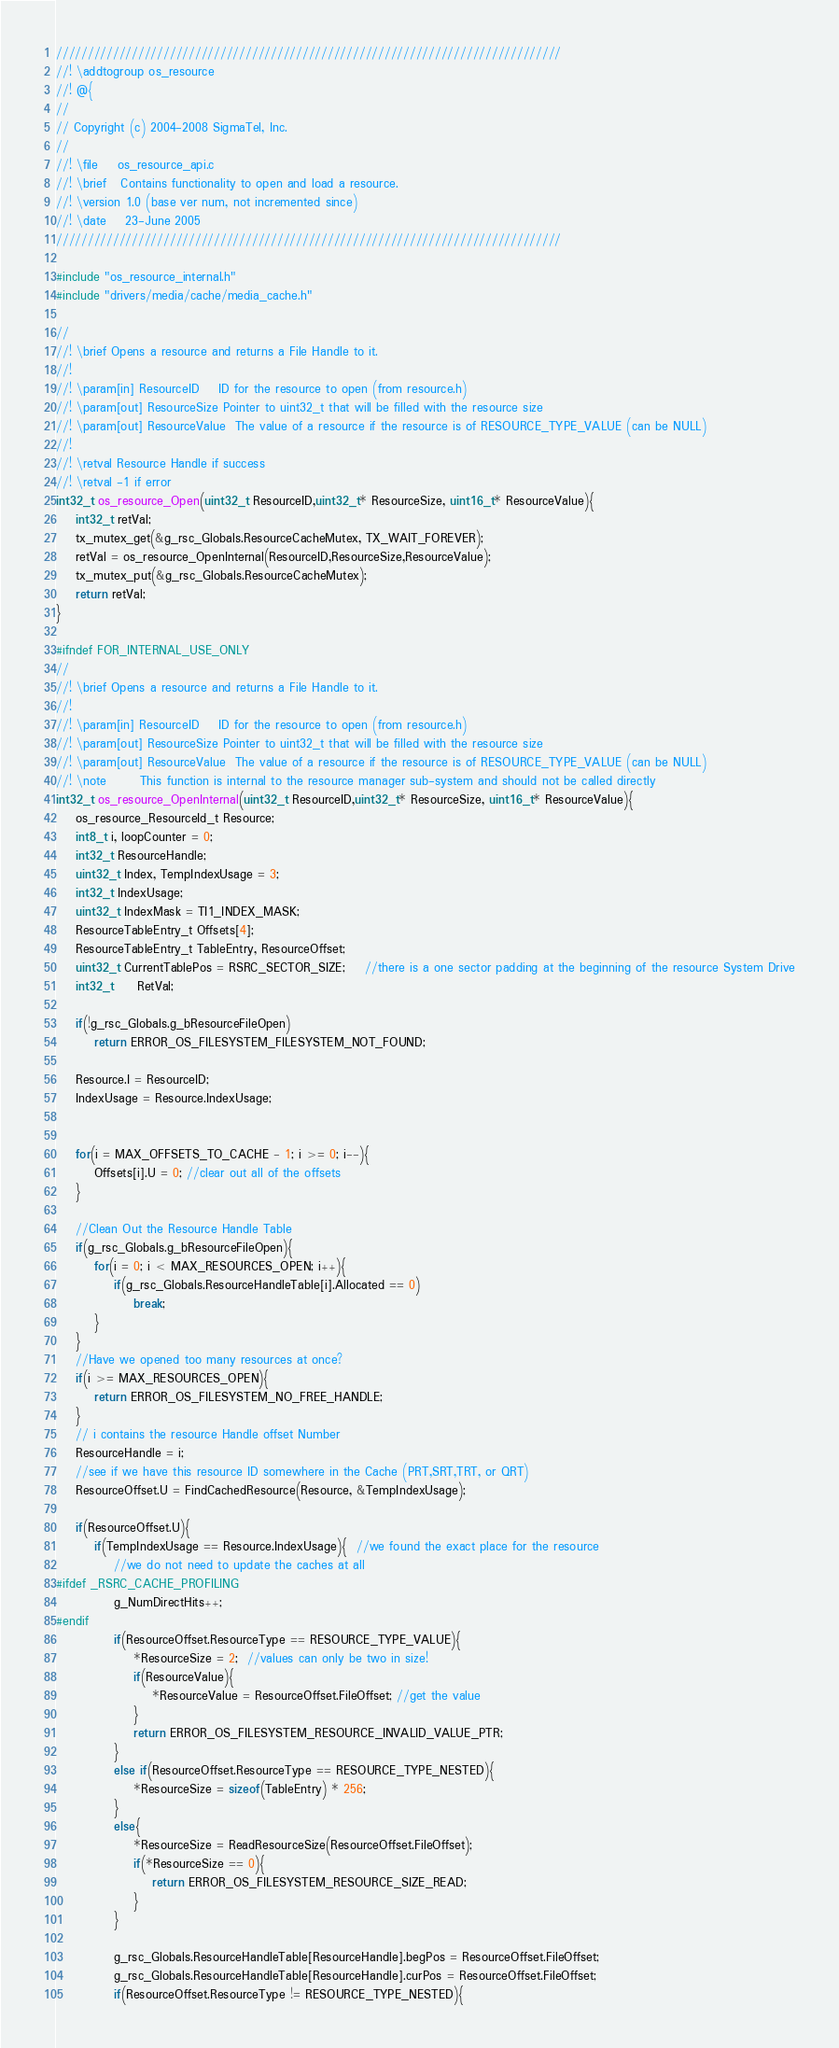Convert code to text. <code><loc_0><loc_0><loc_500><loc_500><_C_>////////////////////////////////////////////////////////////////////////////////
//! \addtogroup os_resource
//! @{
//
// Copyright (c) 2004-2008 SigmaTel, Inc.
//
//! \file    os_resource_api.c
//! \brief   Contains functionality to open and load a resource.
//! \version 1.0 (base ver num, not incremented since)
//! \date    23-June 2005
////////////////////////////////////////////////////////////////////////////////

#include "os_resource_internal.h"
#include "drivers/media/cache/media_cache.h"

//
//! \brief Opens a resource and returns a File Handle to it.
//! 
//! \param[in] ResourceID    ID for the resource to open (from resource.h)
//! \param[out] ResourceSize Pointer to uint32_t that will be filled with the resource size
//! \param[out] ResourceValue  The value of a resource if the resource is of RESOURCE_TYPE_VALUE (can be NULL)
//! 
//! \retval Resource Handle if success
//! \retval -1 if error
int32_t os_resource_Open(uint32_t ResourceID,uint32_t* ResourceSize, uint16_t* ResourceValue){
    int32_t retVal;
    tx_mutex_get(&g_rsc_Globals.ResourceCacheMutex, TX_WAIT_FOREVER);
    retVal = os_resource_OpenInternal(ResourceID,ResourceSize,ResourceValue);
    tx_mutex_put(&g_rsc_Globals.ResourceCacheMutex);
    return retVal;
}

#ifndef FOR_INTERNAL_USE_ONLY
//
//! \brief Opens a resource and returns a File Handle to it.
//! 
//! \param[in] ResourceID    ID for the resource to open (from resource.h)
//! \param[out] ResourceSize Pointer to uint32_t that will be filled with the resource size
//! \param[out] ResourceValue  The value of a resource if the resource is of RESOURCE_TYPE_VALUE (can be NULL)
//! \note       This function is internal to the resource manager sub-system and should not be called directly
int32_t os_resource_OpenInternal(uint32_t ResourceID,uint32_t* ResourceSize, uint16_t* ResourceValue){
    os_resource_ResourceId_t Resource;
    int8_t i, loopCounter = 0;
    int32_t ResourceHandle;
    uint32_t Index, TempIndexUsage = 3; 
    int32_t IndexUsage;
    uint32_t IndexMask = TI1_INDEX_MASK;
    ResourceTableEntry_t Offsets[4];
    ResourceTableEntry_t TableEntry, ResourceOffset;
    uint32_t CurrentTablePos = RSRC_SECTOR_SIZE;	//there is a one sector padding at the beginning of the resource System Drive
    int32_t     RetVal;
    
    if(!g_rsc_Globals.g_bResourceFileOpen)
        return ERROR_OS_FILESYSTEM_FILESYSTEM_NOT_FOUND;
    
    Resource.I = ResourceID;
    IndexUsage = Resource.IndexUsage;


    for(i = MAX_OFFSETS_TO_CACHE - 1; i >= 0; i--){
        Offsets[i].U = 0; //clear out all of the offsets    
    }

	//Clean Out the Resource Handle Table
    if(g_rsc_Globals.g_bResourceFileOpen){
	    for(i = 0; i < MAX_RESOURCES_OPEN; i++){
	        if(g_rsc_Globals.ResourceHandleTable[i].Allocated == 0)
		        break;
	    }
	}
	//Have we opened too many resources at once?
	if(i >= MAX_RESOURCES_OPEN){
        return ERROR_OS_FILESYSTEM_NO_FREE_HANDLE;
	}    
    // i contains the resource Handle offset Number
    ResourceHandle = i;
    //see if we have this resource ID somewhere in the Cache (PRT,SRT,TRT, or QRT)
    ResourceOffset.U = FindCachedResource(Resource, &TempIndexUsage);
    
    if(ResourceOffset.U){
        if(TempIndexUsage == Resource.IndexUsage){  //we found the exact place for the resource
            //we do not need to update the caches at all
#ifdef _RSRC_CACHE_PROFILING            
            g_NumDirectHits++;
#endif
            if(ResourceOffset.ResourceType == RESOURCE_TYPE_VALUE){
                *ResourceSize = 2;  //values can only be two in size!
                if(ResourceValue){
                    *ResourceValue = ResourceOffset.FileOffset; //get the value
                }
                return ERROR_OS_FILESYSTEM_RESOURCE_INVALID_VALUE_PTR;
            }
            else if(ResourceOffset.ResourceType == RESOURCE_TYPE_NESTED){
                *ResourceSize = sizeof(TableEntry) * 256;
            }
            else{
                *ResourceSize = ReadResourceSize(ResourceOffset.FileOffset);
                if(*ResourceSize == 0){
                    return ERROR_OS_FILESYSTEM_RESOURCE_SIZE_READ;
                }
            }

            g_rsc_Globals.ResourceHandleTable[ResourceHandle].begPos = ResourceOffset.FileOffset;
            g_rsc_Globals.ResourceHandleTable[ResourceHandle].curPos = ResourceOffset.FileOffset;
            if(ResourceOffset.ResourceType != RESOURCE_TYPE_NESTED){</code> 